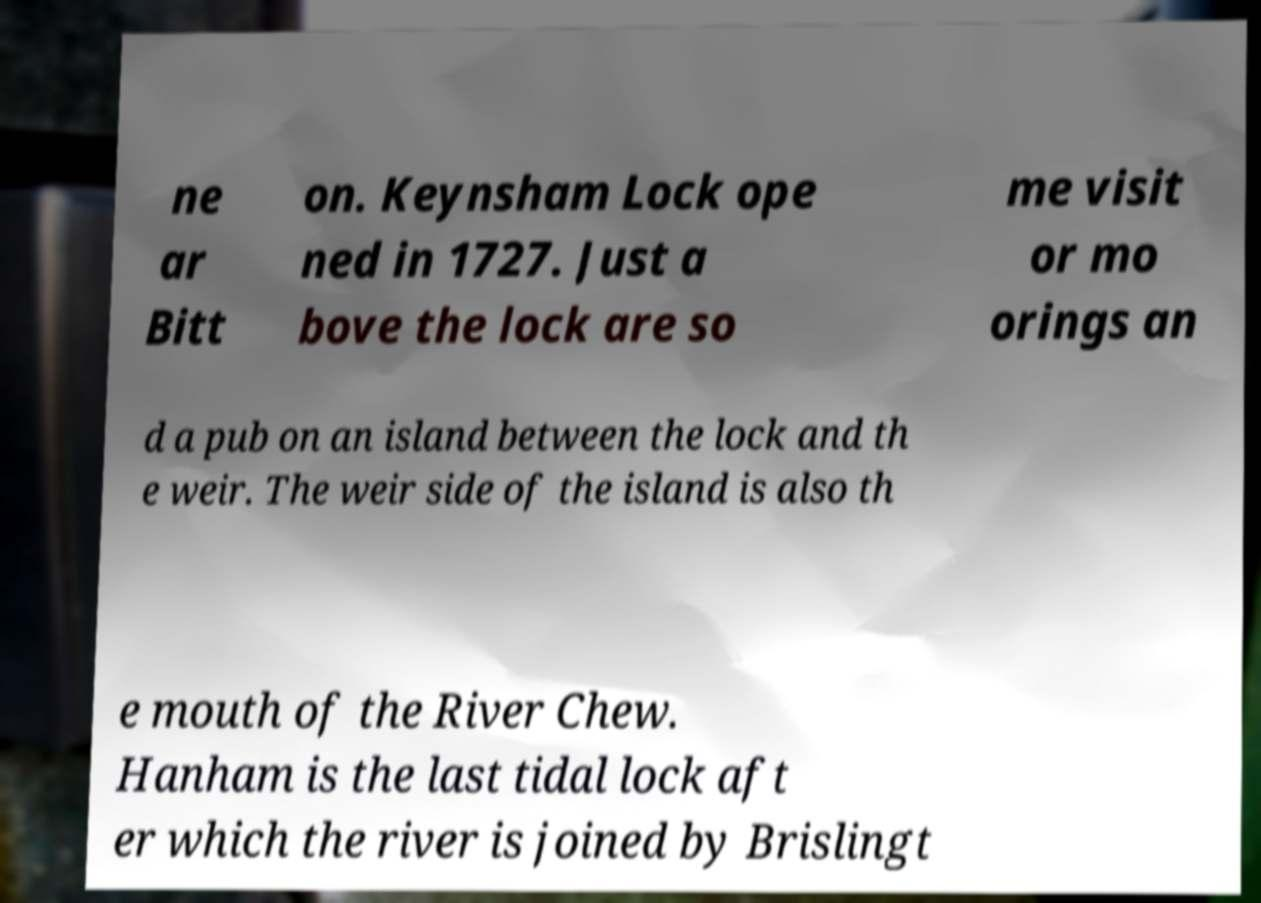I need the written content from this picture converted into text. Can you do that? ne ar Bitt on. Keynsham Lock ope ned in 1727. Just a bove the lock are so me visit or mo orings an d a pub on an island between the lock and th e weir. The weir side of the island is also th e mouth of the River Chew. Hanham is the last tidal lock aft er which the river is joined by Brislingt 